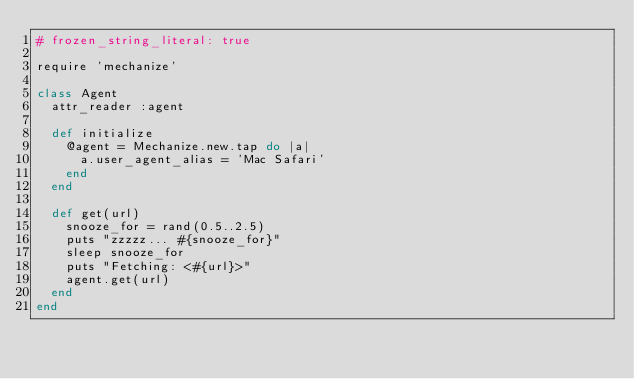Convert code to text. <code><loc_0><loc_0><loc_500><loc_500><_Ruby_># frozen_string_literal: true

require 'mechanize'

class Agent
  attr_reader :agent

  def initialize
    @agent = Mechanize.new.tap do |a|
      a.user_agent_alias = 'Mac Safari'
    end
  end

  def get(url)
    snooze_for = rand(0.5..2.5)
    puts "zzzzz... #{snooze_for}"
    sleep snooze_for
    puts "Fetching: <#{url}>"
    agent.get(url)
  end
end
</code> 